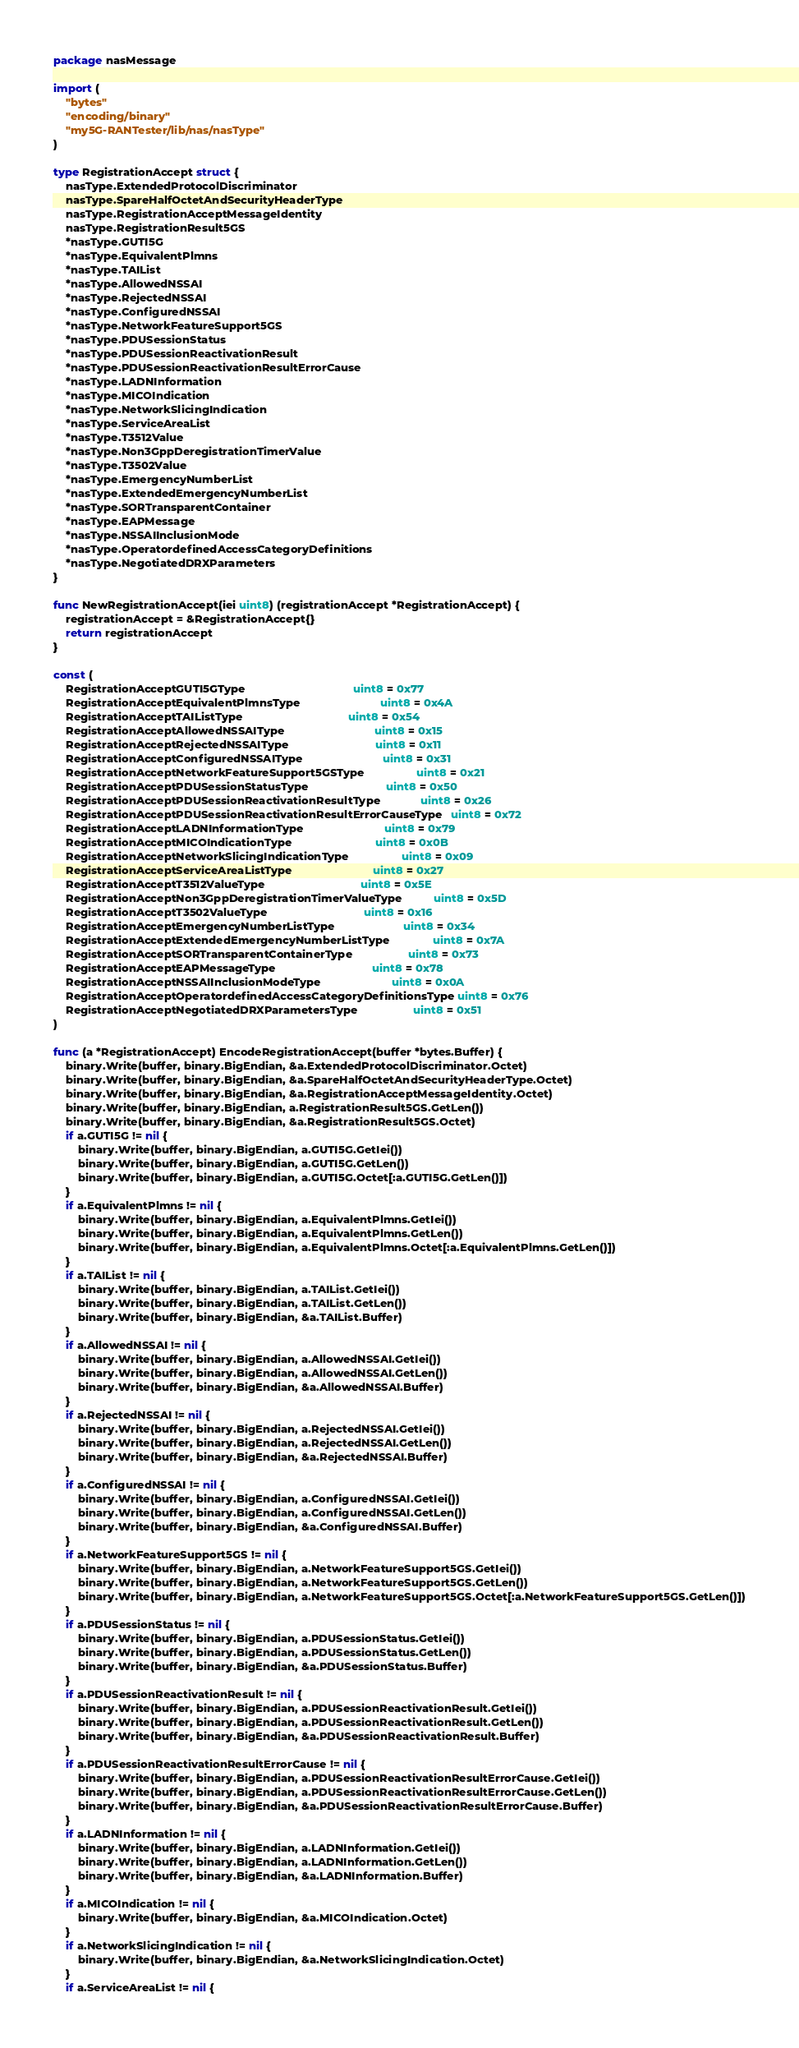<code> <loc_0><loc_0><loc_500><loc_500><_Go_>package nasMessage

import (
	"bytes"
	"encoding/binary"
	"my5G-RANTester/lib/nas/nasType"
)

type RegistrationAccept struct {
	nasType.ExtendedProtocolDiscriminator
	nasType.SpareHalfOctetAndSecurityHeaderType
	nasType.RegistrationAcceptMessageIdentity
	nasType.RegistrationResult5GS
	*nasType.GUTI5G
	*nasType.EquivalentPlmns
	*nasType.TAIList
	*nasType.AllowedNSSAI
	*nasType.RejectedNSSAI
	*nasType.ConfiguredNSSAI
	*nasType.NetworkFeatureSupport5GS
	*nasType.PDUSessionStatus
	*nasType.PDUSessionReactivationResult
	*nasType.PDUSessionReactivationResultErrorCause
	*nasType.LADNInformation
	*nasType.MICOIndication
	*nasType.NetworkSlicingIndication
	*nasType.ServiceAreaList
	*nasType.T3512Value
	*nasType.Non3GppDeregistrationTimerValue
	*nasType.T3502Value
	*nasType.EmergencyNumberList
	*nasType.ExtendedEmergencyNumberList
	*nasType.SORTransparentContainer
	*nasType.EAPMessage
	*nasType.NSSAIInclusionMode
	*nasType.OperatordefinedAccessCategoryDefinitions
	*nasType.NegotiatedDRXParameters
}

func NewRegistrationAccept(iei uint8) (registrationAccept *RegistrationAccept) {
	registrationAccept = &RegistrationAccept{}
	return registrationAccept
}

const (
	RegistrationAcceptGUTI5GType                                   uint8 = 0x77
	RegistrationAcceptEquivalentPlmnsType                          uint8 = 0x4A
	RegistrationAcceptTAIListType                                  uint8 = 0x54
	RegistrationAcceptAllowedNSSAIType                             uint8 = 0x15
	RegistrationAcceptRejectedNSSAIType                            uint8 = 0x11
	RegistrationAcceptConfiguredNSSAIType                          uint8 = 0x31
	RegistrationAcceptNetworkFeatureSupport5GSType                 uint8 = 0x21
	RegistrationAcceptPDUSessionStatusType                         uint8 = 0x50
	RegistrationAcceptPDUSessionReactivationResultType             uint8 = 0x26
	RegistrationAcceptPDUSessionReactivationResultErrorCauseType   uint8 = 0x72
	RegistrationAcceptLADNInformationType                          uint8 = 0x79
	RegistrationAcceptMICOIndicationType                           uint8 = 0x0B
	RegistrationAcceptNetworkSlicingIndicationType                 uint8 = 0x09
	RegistrationAcceptServiceAreaListType                          uint8 = 0x27
	RegistrationAcceptT3512ValueType                               uint8 = 0x5E
	RegistrationAcceptNon3GppDeregistrationTimerValueType          uint8 = 0x5D
	RegistrationAcceptT3502ValueType                               uint8 = 0x16
	RegistrationAcceptEmergencyNumberListType                      uint8 = 0x34
	RegistrationAcceptExtendedEmergencyNumberListType              uint8 = 0x7A
	RegistrationAcceptSORTransparentContainerType                  uint8 = 0x73
	RegistrationAcceptEAPMessageType                               uint8 = 0x78
	RegistrationAcceptNSSAIInclusionModeType                       uint8 = 0x0A
	RegistrationAcceptOperatordefinedAccessCategoryDefinitionsType uint8 = 0x76
	RegistrationAcceptNegotiatedDRXParametersType                  uint8 = 0x51
)

func (a *RegistrationAccept) EncodeRegistrationAccept(buffer *bytes.Buffer) {
	binary.Write(buffer, binary.BigEndian, &a.ExtendedProtocolDiscriminator.Octet)
	binary.Write(buffer, binary.BigEndian, &a.SpareHalfOctetAndSecurityHeaderType.Octet)
	binary.Write(buffer, binary.BigEndian, &a.RegistrationAcceptMessageIdentity.Octet)
	binary.Write(buffer, binary.BigEndian, a.RegistrationResult5GS.GetLen())
	binary.Write(buffer, binary.BigEndian, &a.RegistrationResult5GS.Octet)
	if a.GUTI5G != nil {
		binary.Write(buffer, binary.BigEndian, a.GUTI5G.GetIei())
		binary.Write(buffer, binary.BigEndian, a.GUTI5G.GetLen())
		binary.Write(buffer, binary.BigEndian, a.GUTI5G.Octet[:a.GUTI5G.GetLen()])
	}
	if a.EquivalentPlmns != nil {
		binary.Write(buffer, binary.BigEndian, a.EquivalentPlmns.GetIei())
		binary.Write(buffer, binary.BigEndian, a.EquivalentPlmns.GetLen())
		binary.Write(buffer, binary.BigEndian, a.EquivalentPlmns.Octet[:a.EquivalentPlmns.GetLen()])
	}
	if a.TAIList != nil {
		binary.Write(buffer, binary.BigEndian, a.TAIList.GetIei())
		binary.Write(buffer, binary.BigEndian, a.TAIList.GetLen())
		binary.Write(buffer, binary.BigEndian, &a.TAIList.Buffer)
	}
	if a.AllowedNSSAI != nil {
		binary.Write(buffer, binary.BigEndian, a.AllowedNSSAI.GetIei())
		binary.Write(buffer, binary.BigEndian, a.AllowedNSSAI.GetLen())
		binary.Write(buffer, binary.BigEndian, &a.AllowedNSSAI.Buffer)
	}
	if a.RejectedNSSAI != nil {
		binary.Write(buffer, binary.BigEndian, a.RejectedNSSAI.GetIei())
		binary.Write(buffer, binary.BigEndian, a.RejectedNSSAI.GetLen())
		binary.Write(buffer, binary.BigEndian, &a.RejectedNSSAI.Buffer)
	}
	if a.ConfiguredNSSAI != nil {
		binary.Write(buffer, binary.BigEndian, a.ConfiguredNSSAI.GetIei())
		binary.Write(buffer, binary.BigEndian, a.ConfiguredNSSAI.GetLen())
		binary.Write(buffer, binary.BigEndian, &a.ConfiguredNSSAI.Buffer)
	}
	if a.NetworkFeatureSupport5GS != nil {
		binary.Write(buffer, binary.BigEndian, a.NetworkFeatureSupport5GS.GetIei())
		binary.Write(buffer, binary.BigEndian, a.NetworkFeatureSupport5GS.GetLen())
		binary.Write(buffer, binary.BigEndian, a.NetworkFeatureSupport5GS.Octet[:a.NetworkFeatureSupport5GS.GetLen()])
	}
	if a.PDUSessionStatus != nil {
		binary.Write(buffer, binary.BigEndian, a.PDUSessionStatus.GetIei())
		binary.Write(buffer, binary.BigEndian, a.PDUSessionStatus.GetLen())
		binary.Write(buffer, binary.BigEndian, &a.PDUSessionStatus.Buffer)
	}
	if a.PDUSessionReactivationResult != nil {
		binary.Write(buffer, binary.BigEndian, a.PDUSessionReactivationResult.GetIei())
		binary.Write(buffer, binary.BigEndian, a.PDUSessionReactivationResult.GetLen())
		binary.Write(buffer, binary.BigEndian, &a.PDUSessionReactivationResult.Buffer)
	}
	if a.PDUSessionReactivationResultErrorCause != nil {
		binary.Write(buffer, binary.BigEndian, a.PDUSessionReactivationResultErrorCause.GetIei())
		binary.Write(buffer, binary.BigEndian, a.PDUSessionReactivationResultErrorCause.GetLen())
		binary.Write(buffer, binary.BigEndian, &a.PDUSessionReactivationResultErrorCause.Buffer)
	}
	if a.LADNInformation != nil {
		binary.Write(buffer, binary.BigEndian, a.LADNInformation.GetIei())
		binary.Write(buffer, binary.BigEndian, a.LADNInformation.GetLen())
		binary.Write(buffer, binary.BigEndian, &a.LADNInformation.Buffer)
	}
	if a.MICOIndication != nil {
		binary.Write(buffer, binary.BigEndian, &a.MICOIndication.Octet)
	}
	if a.NetworkSlicingIndication != nil {
		binary.Write(buffer, binary.BigEndian, &a.NetworkSlicingIndication.Octet)
	}
	if a.ServiceAreaList != nil {</code> 